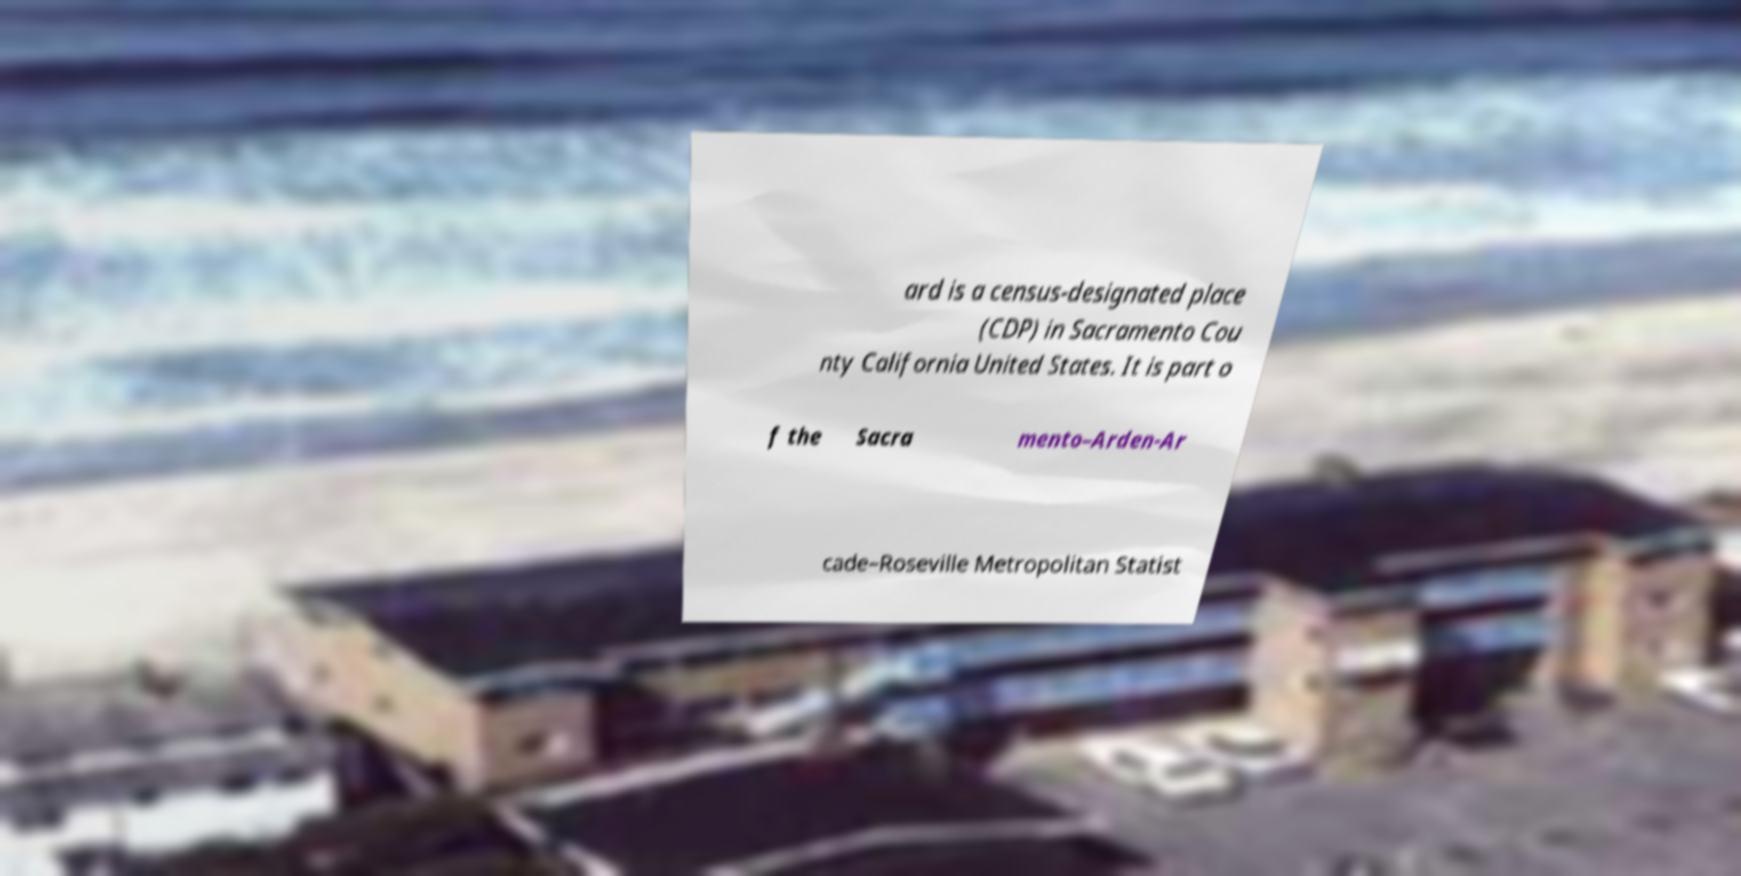Please identify and transcribe the text found in this image. ard is a census-designated place (CDP) in Sacramento Cou nty California United States. It is part o f the Sacra mento–Arden-Ar cade–Roseville Metropolitan Statist 